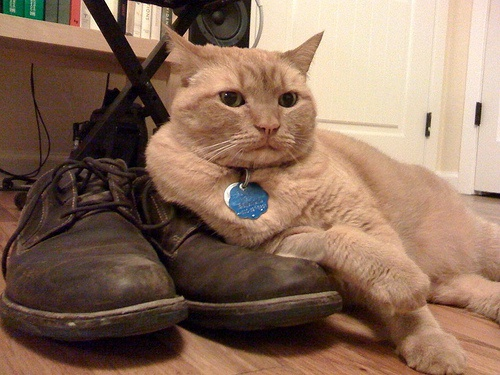Describe the objects in this image and their specific colors. I can see cat in black, tan, and gray tones, chair in black, tan, and beige tones, book in black and tan tones, book in black, gray, and darkgreen tones, and book in black, beige, and tan tones in this image. 